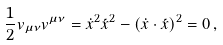Convert formula to latex. <formula><loc_0><loc_0><loc_500><loc_500>\frac { 1 } { 2 } v _ { \mu \nu } v ^ { \mu \nu } = \dot { x } ^ { 2 } \acute { x } ^ { 2 } - ( \dot { x } \cdot \acute { x } ) ^ { 2 } = 0 \, ,</formula> 